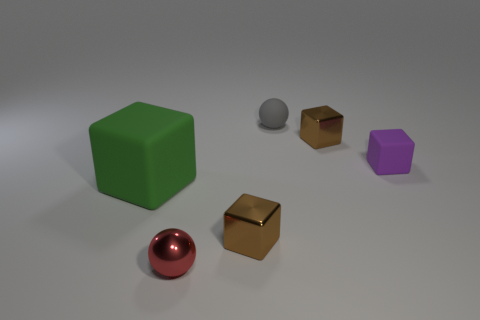What might be the material of the objects based on their appearance? Based on the image, the large green cube appears to be made of a matte, slightly textured material, possibly plastic. The shiny red sphere looks like it could be made of polished metal due to its reflective surface. The small gray sphere seems to be made of rubber, judging by its dull, non-reflective finish. The two small golden cubes give off a metallic sheen, suggesting they are also made of metal. Lastly, the medium-sized purple object has a matte finish, indicating it might be made of plastic or perhaps a coated metal. 